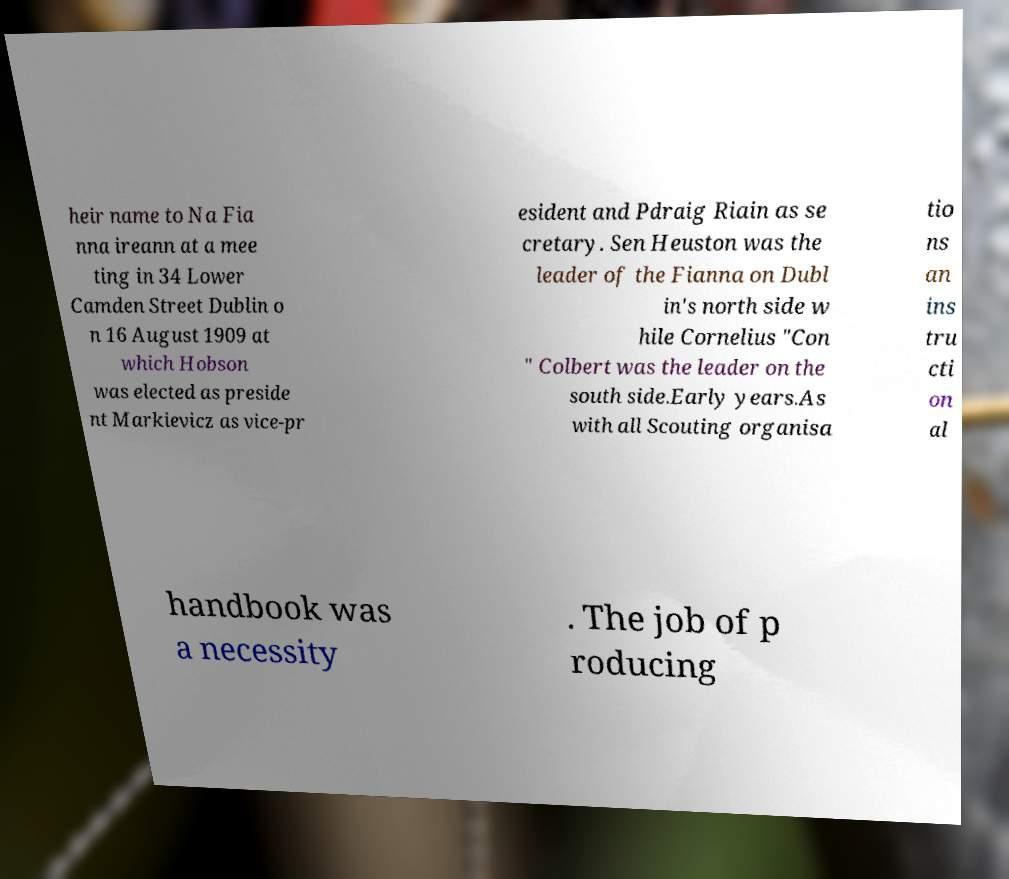Can you read and provide the text displayed in the image?This photo seems to have some interesting text. Can you extract and type it out for me? heir name to Na Fia nna ireann at a mee ting in 34 Lower Camden Street Dublin o n 16 August 1909 at which Hobson was elected as preside nt Markievicz as vice-pr esident and Pdraig Riain as se cretary. Sen Heuston was the leader of the Fianna on Dubl in's north side w hile Cornelius "Con " Colbert was the leader on the south side.Early years.As with all Scouting organisa tio ns an ins tru cti on al handbook was a necessity . The job of p roducing 